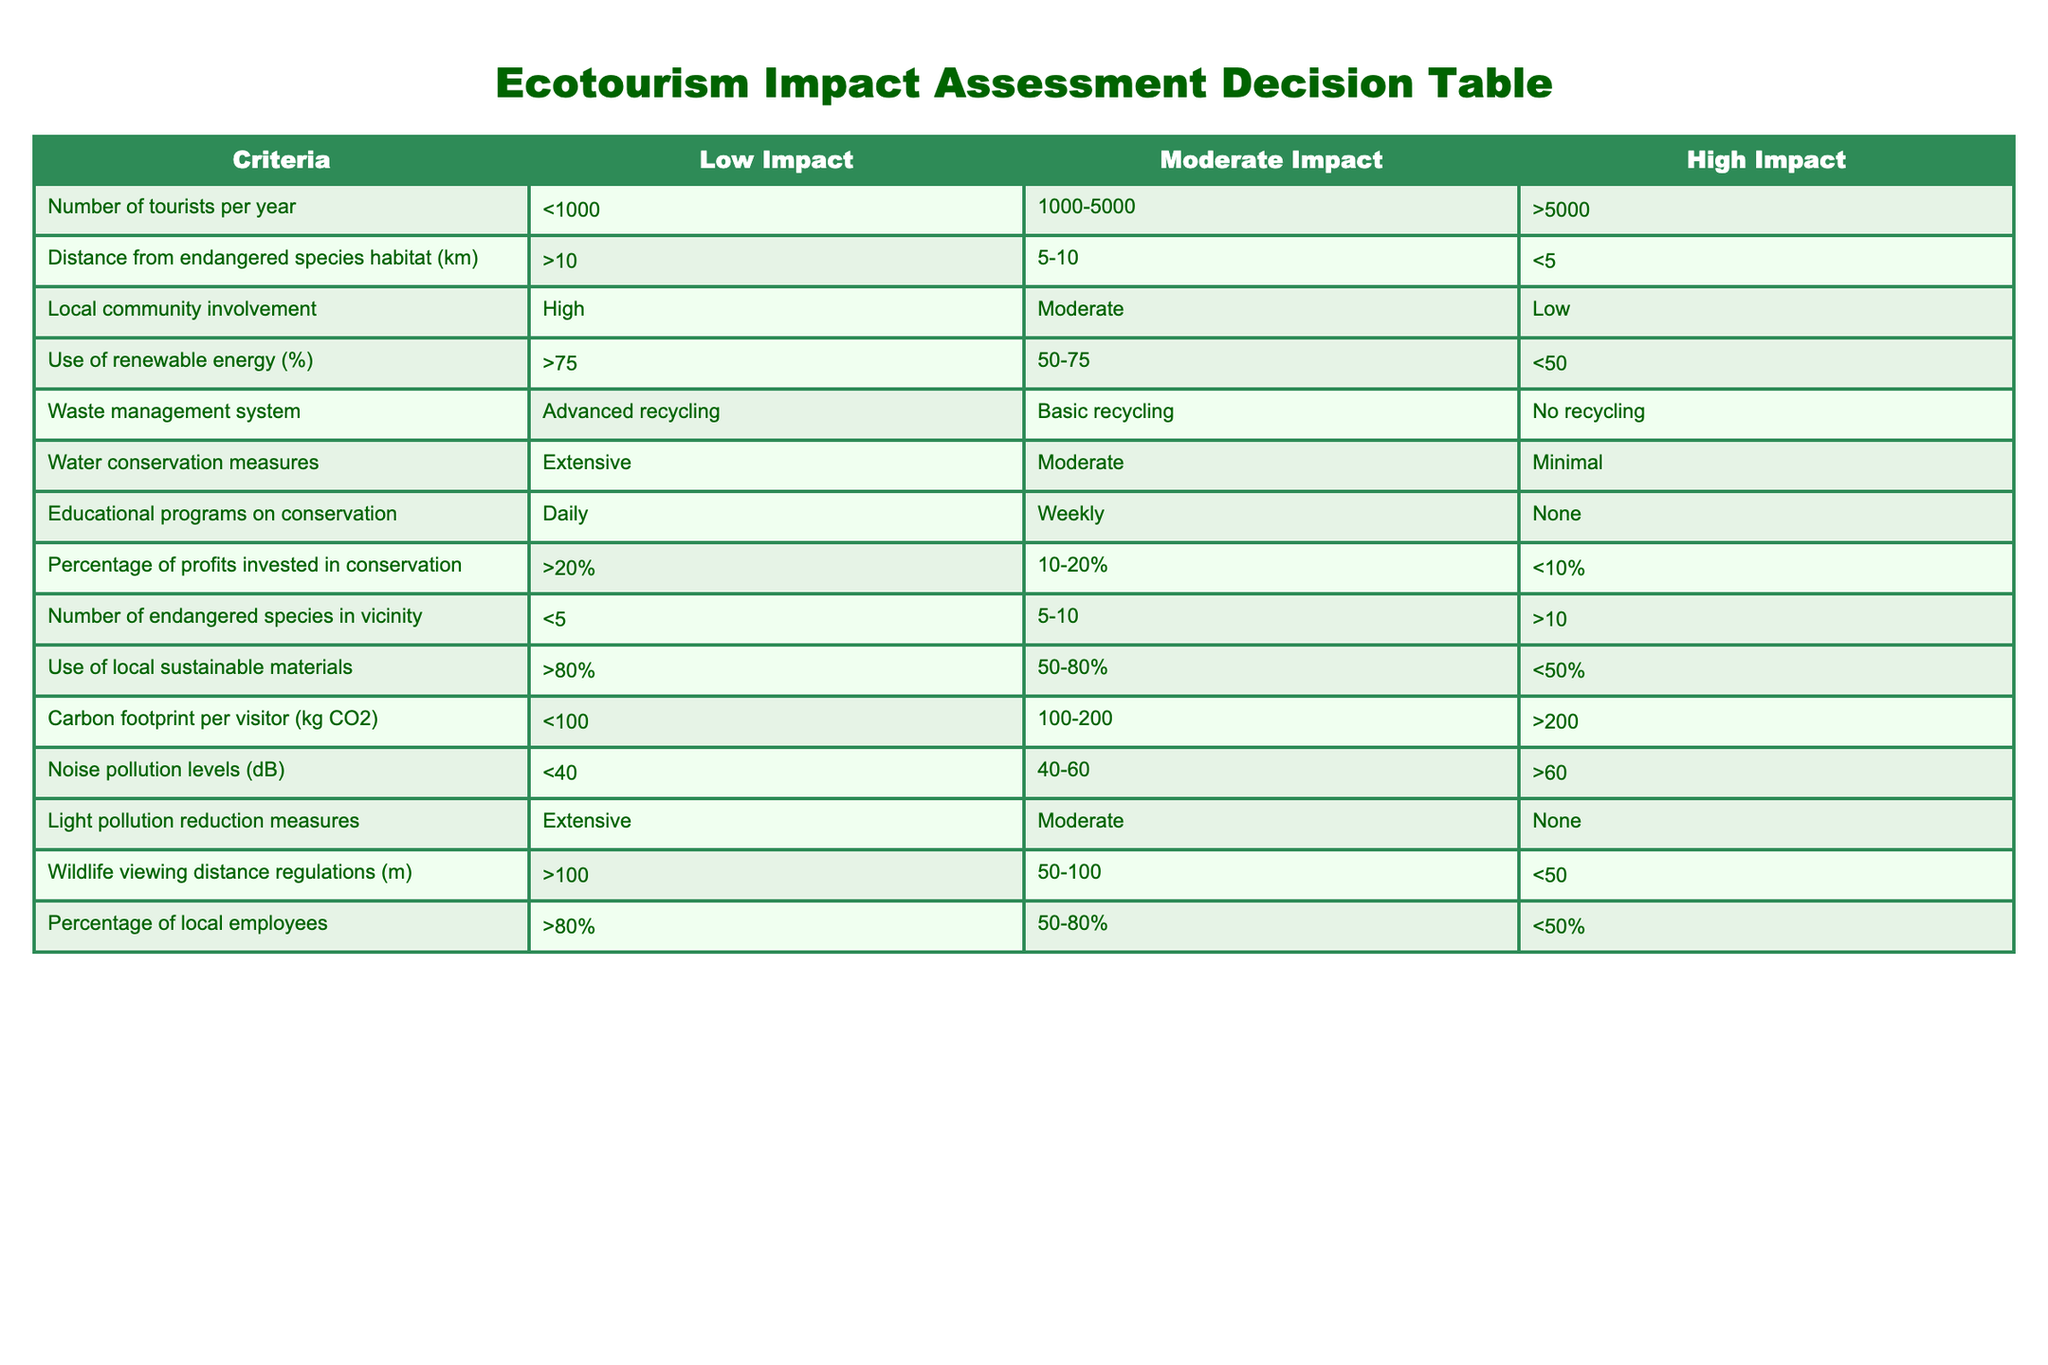What is the maximum number of tourists per year for a low impact ecotourism operation? According to the table, the maximum number of tourists per year classified under 'Low Impact' is less than 1000.
Answer: <1000 What percentage of profits must be invested in conservation for a high impact ecotourism operation? The table states that for 'High Impact' operations, the percentage of profits invested in conservation is less than 10%.
Answer: <10% Is extensive water conservation measures a characteristic of moderate impact ecotourism? The table indicates that moderate impact ecotourism is associated with 'Moderate' water conservation measures, not extensive. Therefore, the statement is false.
Answer: False How many endangered species in vicinity classify as high impact? The table shows that having more than 10 endangered species in the vicinity qualifies as 'High Impact'.
Answer: >10 What is the carbon footprint per visitor for low impact ecotourism? The table specifies that a low impact ecotourism operation must have a carbon footprint per visitor of less than 100 kg CO2.
Answer: <100 What combination of local community involvement and number of endangered species in the vicinity represents a moderate impact? A 'Moderate Impact' requires moderate community involvement and between 5 to 10 endangered species in the vicinity, which can be found in the table.
Answer: Moderate involvement with 5-10 species Can there be a high impact ecotourism operation if the distance from endangered species habitat is 7 km? Yes, according to the table, a distance of 5-10 km from endangered species habitat would classify as 'Moderate Impact', while a distance of less than 5 km would be 'High Impact'. Thus, 7 km gives a moderate impact, not a high one.
Answer: Yes What is the average distance from endangered species habitat for moderate impact operations? The distances for 'Moderate Impact' range from 5 to 10 km. The average of these two values (5 and 10) can be calculated: (5 + 10) / 2 = 7.5 km. Thus, the average distance is 7.5 km.
Answer: 7.5 km How many characteristics are displayed under high impact ecotourism? The table shows 10 criteria or characteristics displayed under 'High Impact'. This includes factors such as number of tourists, community involvement, and energy use, among others.
Answer: 10 